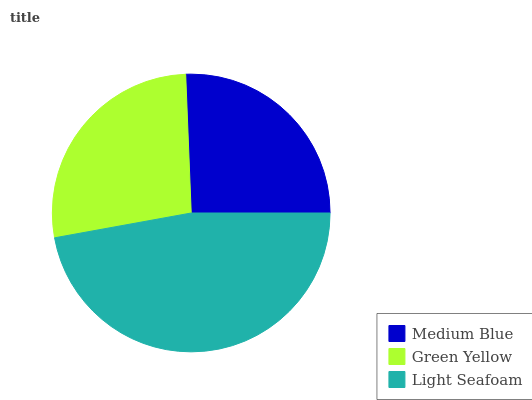Is Medium Blue the minimum?
Answer yes or no. Yes. Is Light Seafoam the maximum?
Answer yes or no. Yes. Is Green Yellow the minimum?
Answer yes or no. No. Is Green Yellow the maximum?
Answer yes or no. No. Is Green Yellow greater than Medium Blue?
Answer yes or no. Yes. Is Medium Blue less than Green Yellow?
Answer yes or no. Yes. Is Medium Blue greater than Green Yellow?
Answer yes or no. No. Is Green Yellow less than Medium Blue?
Answer yes or no. No. Is Green Yellow the high median?
Answer yes or no. Yes. Is Green Yellow the low median?
Answer yes or no. Yes. Is Medium Blue the high median?
Answer yes or no. No. Is Medium Blue the low median?
Answer yes or no. No. 